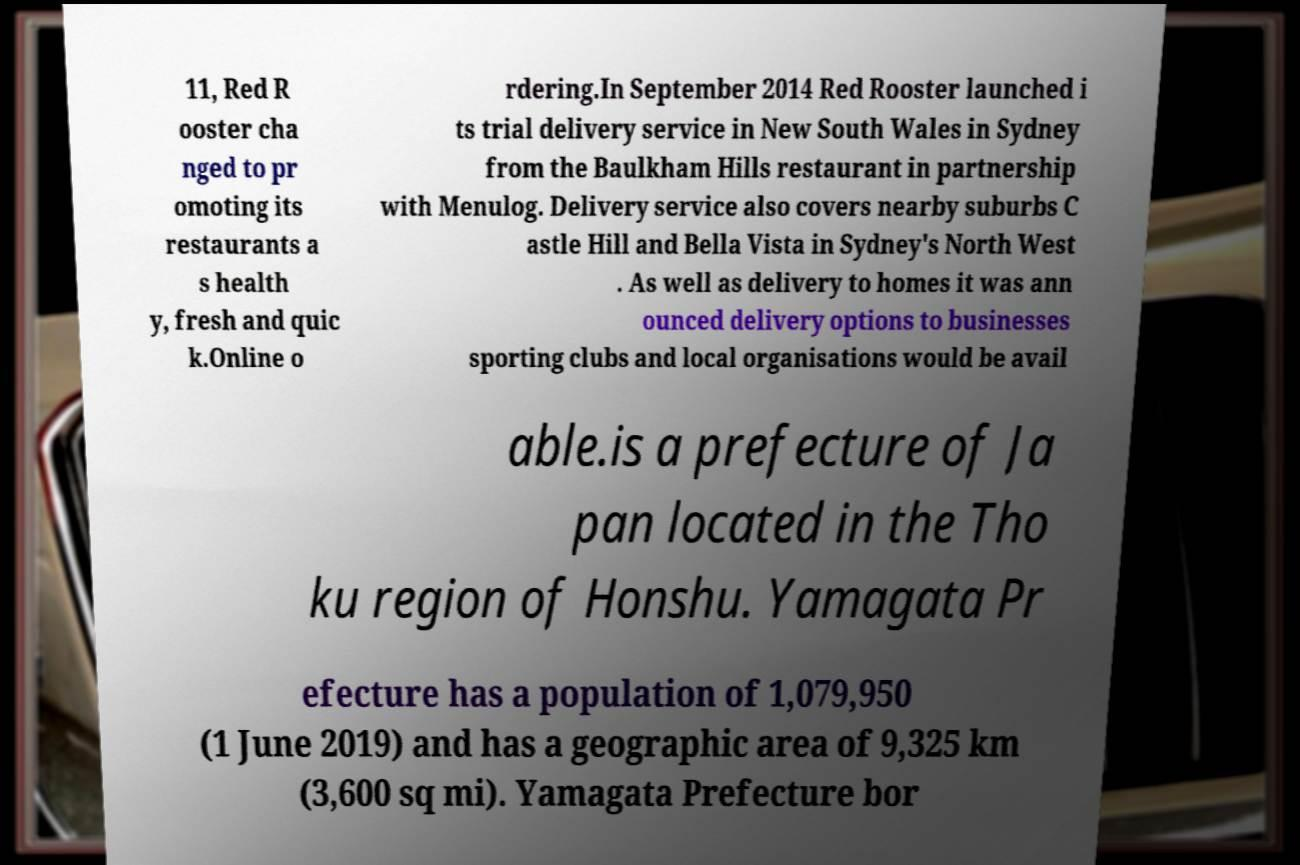Could you assist in decoding the text presented in this image and type it out clearly? 11, Red R ooster cha nged to pr omoting its restaurants a s health y, fresh and quic k.Online o rdering.In September 2014 Red Rooster launched i ts trial delivery service in New South Wales in Sydney from the Baulkham Hills restaurant in partnership with Menulog. Delivery service also covers nearby suburbs C astle Hill and Bella Vista in Sydney's North West . As well as delivery to homes it was ann ounced delivery options to businesses sporting clubs and local organisations would be avail able.is a prefecture of Ja pan located in the Tho ku region of Honshu. Yamagata Pr efecture has a population of 1,079,950 (1 June 2019) and has a geographic area of 9,325 km (3,600 sq mi). Yamagata Prefecture bor 